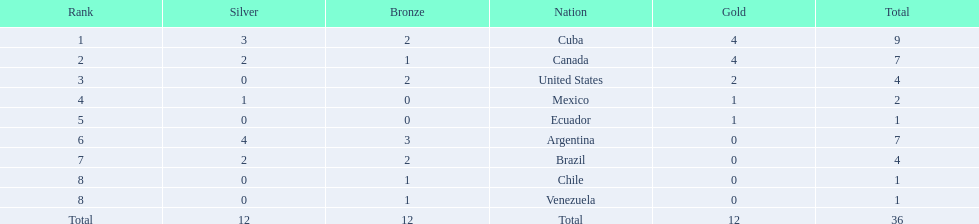What countries participated? Cuba, 4, 3, 2, Canada, 4, 2, 1, United States, 2, 0, 2, Mexico, 1, 1, 0, Ecuador, 1, 0, 0, Argentina, 0, 4, 3, Brazil, 0, 2, 2, Chile, 0, 0, 1, Venezuela, 0, 0, 1. What countries won 1 gold Mexico, 1, 1, 0, Ecuador, 1, 0, 0. What country above also won no silver? Ecuador. 